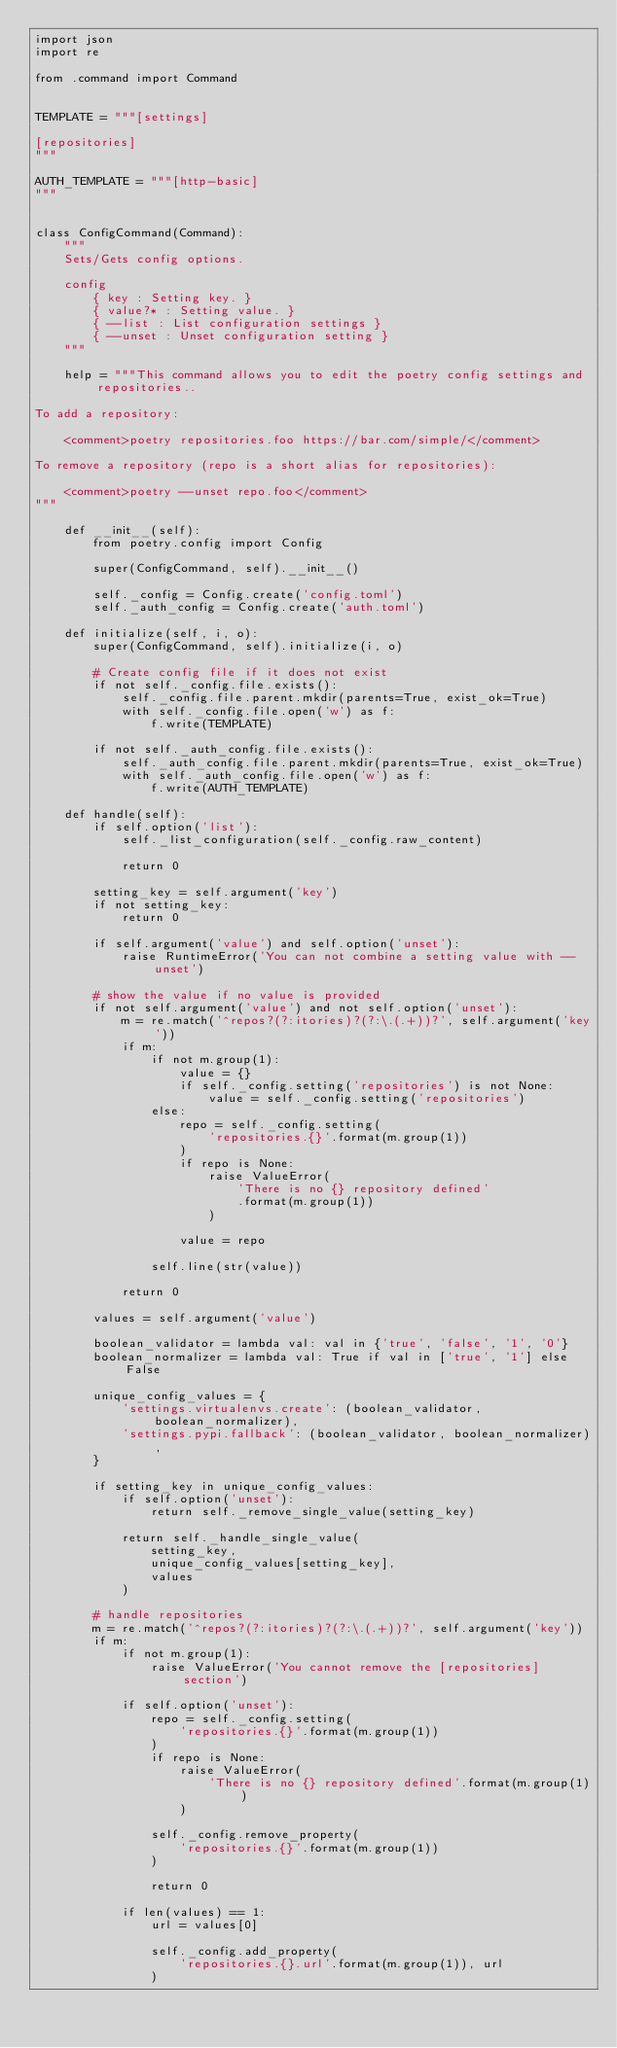Convert code to text. <code><loc_0><loc_0><loc_500><loc_500><_Python_>import json
import re

from .command import Command


TEMPLATE = """[settings]

[repositories]
"""

AUTH_TEMPLATE = """[http-basic]
"""


class ConfigCommand(Command):
    """
    Sets/Gets config options.

    config
        { key : Setting key. }
        { value?* : Setting value. }
        { --list : List configuration settings }
        { --unset : Unset configuration setting }
    """

    help = """This command allows you to edit the poetry config settings and repositories..

To add a repository:

    <comment>poetry repositories.foo https://bar.com/simple/</comment>

To remove a repository (repo is a short alias for repositories):

    <comment>poetry --unset repo.foo</comment>
"""

    def __init__(self):
        from poetry.config import Config

        super(ConfigCommand, self).__init__()

        self._config = Config.create('config.toml')
        self._auth_config = Config.create('auth.toml')

    def initialize(self, i, o):
        super(ConfigCommand, self).initialize(i, o)

        # Create config file if it does not exist
        if not self._config.file.exists():
            self._config.file.parent.mkdir(parents=True, exist_ok=True)
            with self._config.file.open('w') as f:
                f.write(TEMPLATE)

        if not self._auth_config.file.exists():
            self._auth_config.file.parent.mkdir(parents=True, exist_ok=True)
            with self._auth_config.file.open('w') as f:
                f.write(AUTH_TEMPLATE)

    def handle(self):
        if self.option('list'):
            self._list_configuration(self._config.raw_content)

            return 0

        setting_key = self.argument('key')
        if not setting_key:
            return 0

        if self.argument('value') and self.option('unset'):
            raise RuntimeError('You can not combine a setting value with --unset')

        # show the value if no value is provided
        if not self.argument('value') and not self.option('unset'):
            m = re.match('^repos?(?:itories)?(?:\.(.+))?', self.argument('key'))
            if m:
                if not m.group(1):
                    value = {}
                    if self._config.setting('repositories') is not None:
                        value = self._config.setting('repositories')
                else:
                    repo = self._config.setting(
                        'repositories.{}'.format(m.group(1))
                    )
                    if repo is None:
                        raise ValueError(
                            'There is no {} repository defined'
                            .format(m.group(1))
                        )

                    value = repo

                self.line(str(value))

            return 0

        values = self.argument('value')

        boolean_validator = lambda val: val in {'true', 'false', '1', '0'}
        boolean_normalizer = lambda val: True if val in ['true', '1'] else False

        unique_config_values = {
            'settings.virtualenvs.create': (boolean_validator, boolean_normalizer),
            'settings.pypi.fallback': (boolean_validator, boolean_normalizer),
        }

        if setting_key in unique_config_values:
            if self.option('unset'):
                return self._remove_single_value(setting_key)

            return self._handle_single_value(
                setting_key,
                unique_config_values[setting_key],
                values
            )

        # handle repositories
        m = re.match('^repos?(?:itories)?(?:\.(.+))?', self.argument('key'))
        if m:
            if not m.group(1):
                raise ValueError('You cannot remove the [repositories] section')

            if self.option('unset'):
                repo = self._config.setting(
                    'repositories.{}'.format(m.group(1))
                )
                if repo is None:
                    raise ValueError(
                        'There is no {} repository defined'.format(m.group(1))
                    )

                self._config.remove_property(
                    'repositories.{}'.format(m.group(1))
                )

                return 0

            if len(values) == 1:
                url = values[0]

                self._config.add_property(
                    'repositories.{}.url'.format(m.group(1)), url
                )
</code> 